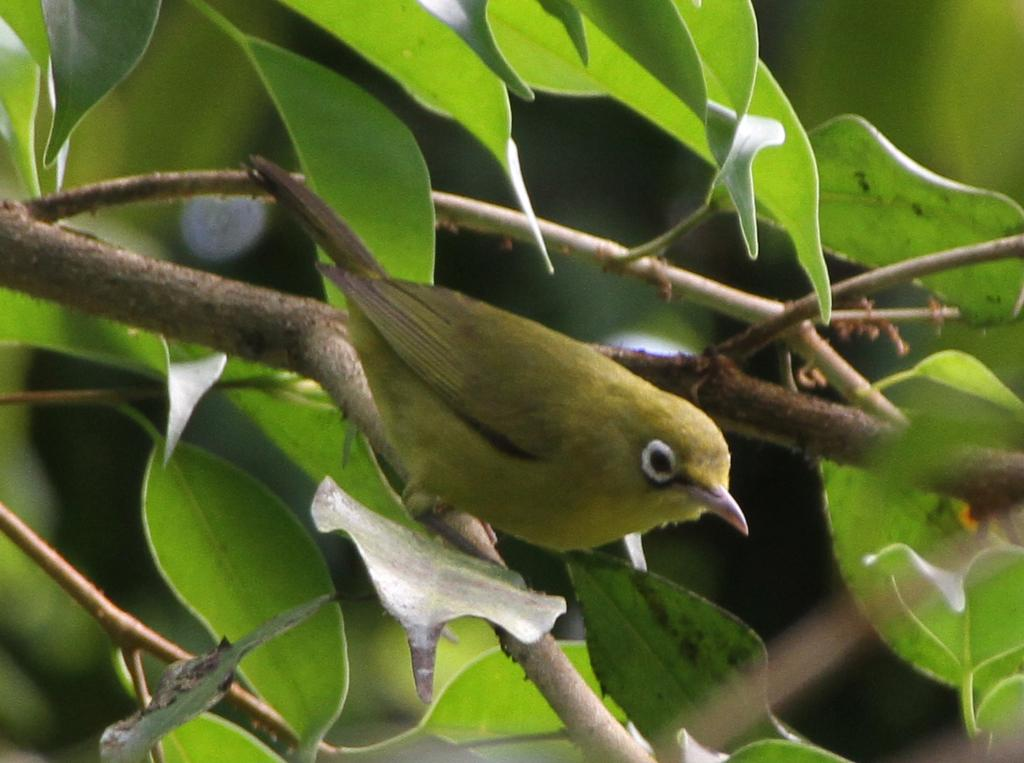What is the main subject of the image? There is a bird on a stem in the image. What can be seen in the background of the image? There are trees in the background of the image. How would you describe the appearance of the background? The background appears blurry. How many mice are visible in the image? There are no mice present in the image. What type of cough medicine is the bird using in the image? There is no cough medicine or any indication of a cough in the image; it features a bird on a stem with trees in the background. 